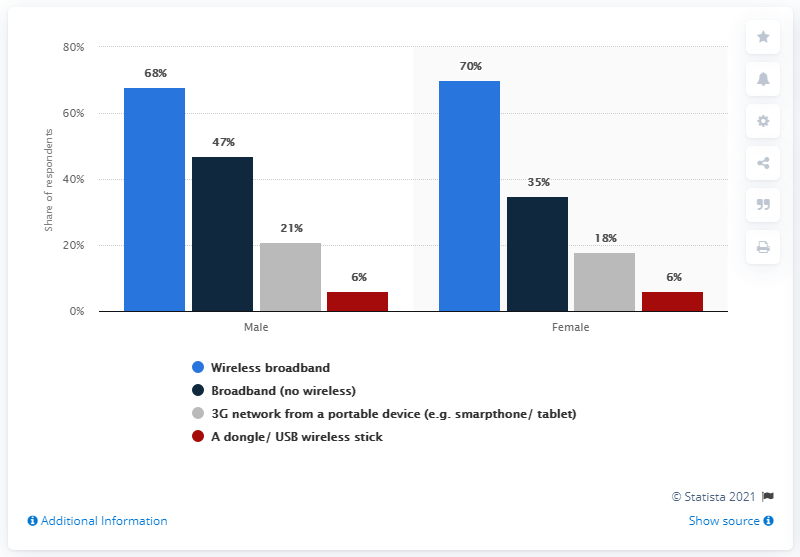Specify some key components in this picture. The value of the highest blue bar is 70. The difference in internet access between the highest access among males in the UK and the lowest access among females is 62%. 